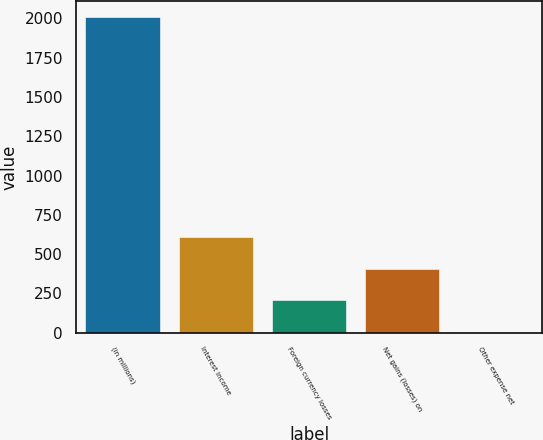<chart> <loc_0><loc_0><loc_500><loc_500><bar_chart><fcel>(in millions)<fcel>Interest income<fcel>Foreign currency losses<fcel>Net gains (losses) on<fcel>Other expense net<nl><fcel>2010<fcel>607.2<fcel>206.4<fcel>406.8<fcel>6<nl></chart> 